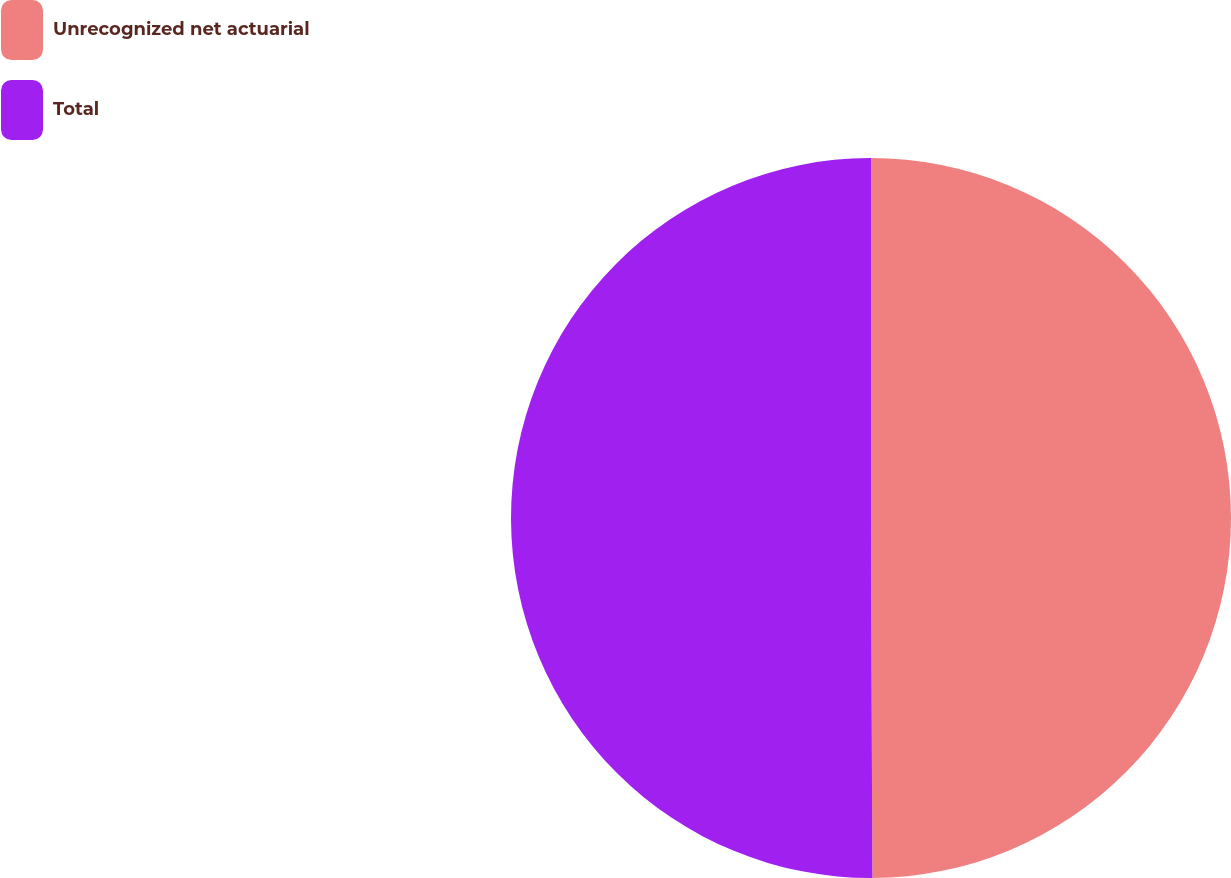Convert chart. <chart><loc_0><loc_0><loc_500><loc_500><pie_chart><fcel>Unrecognized net actuarial<fcel>Total<nl><fcel>49.94%<fcel>50.06%<nl></chart> 